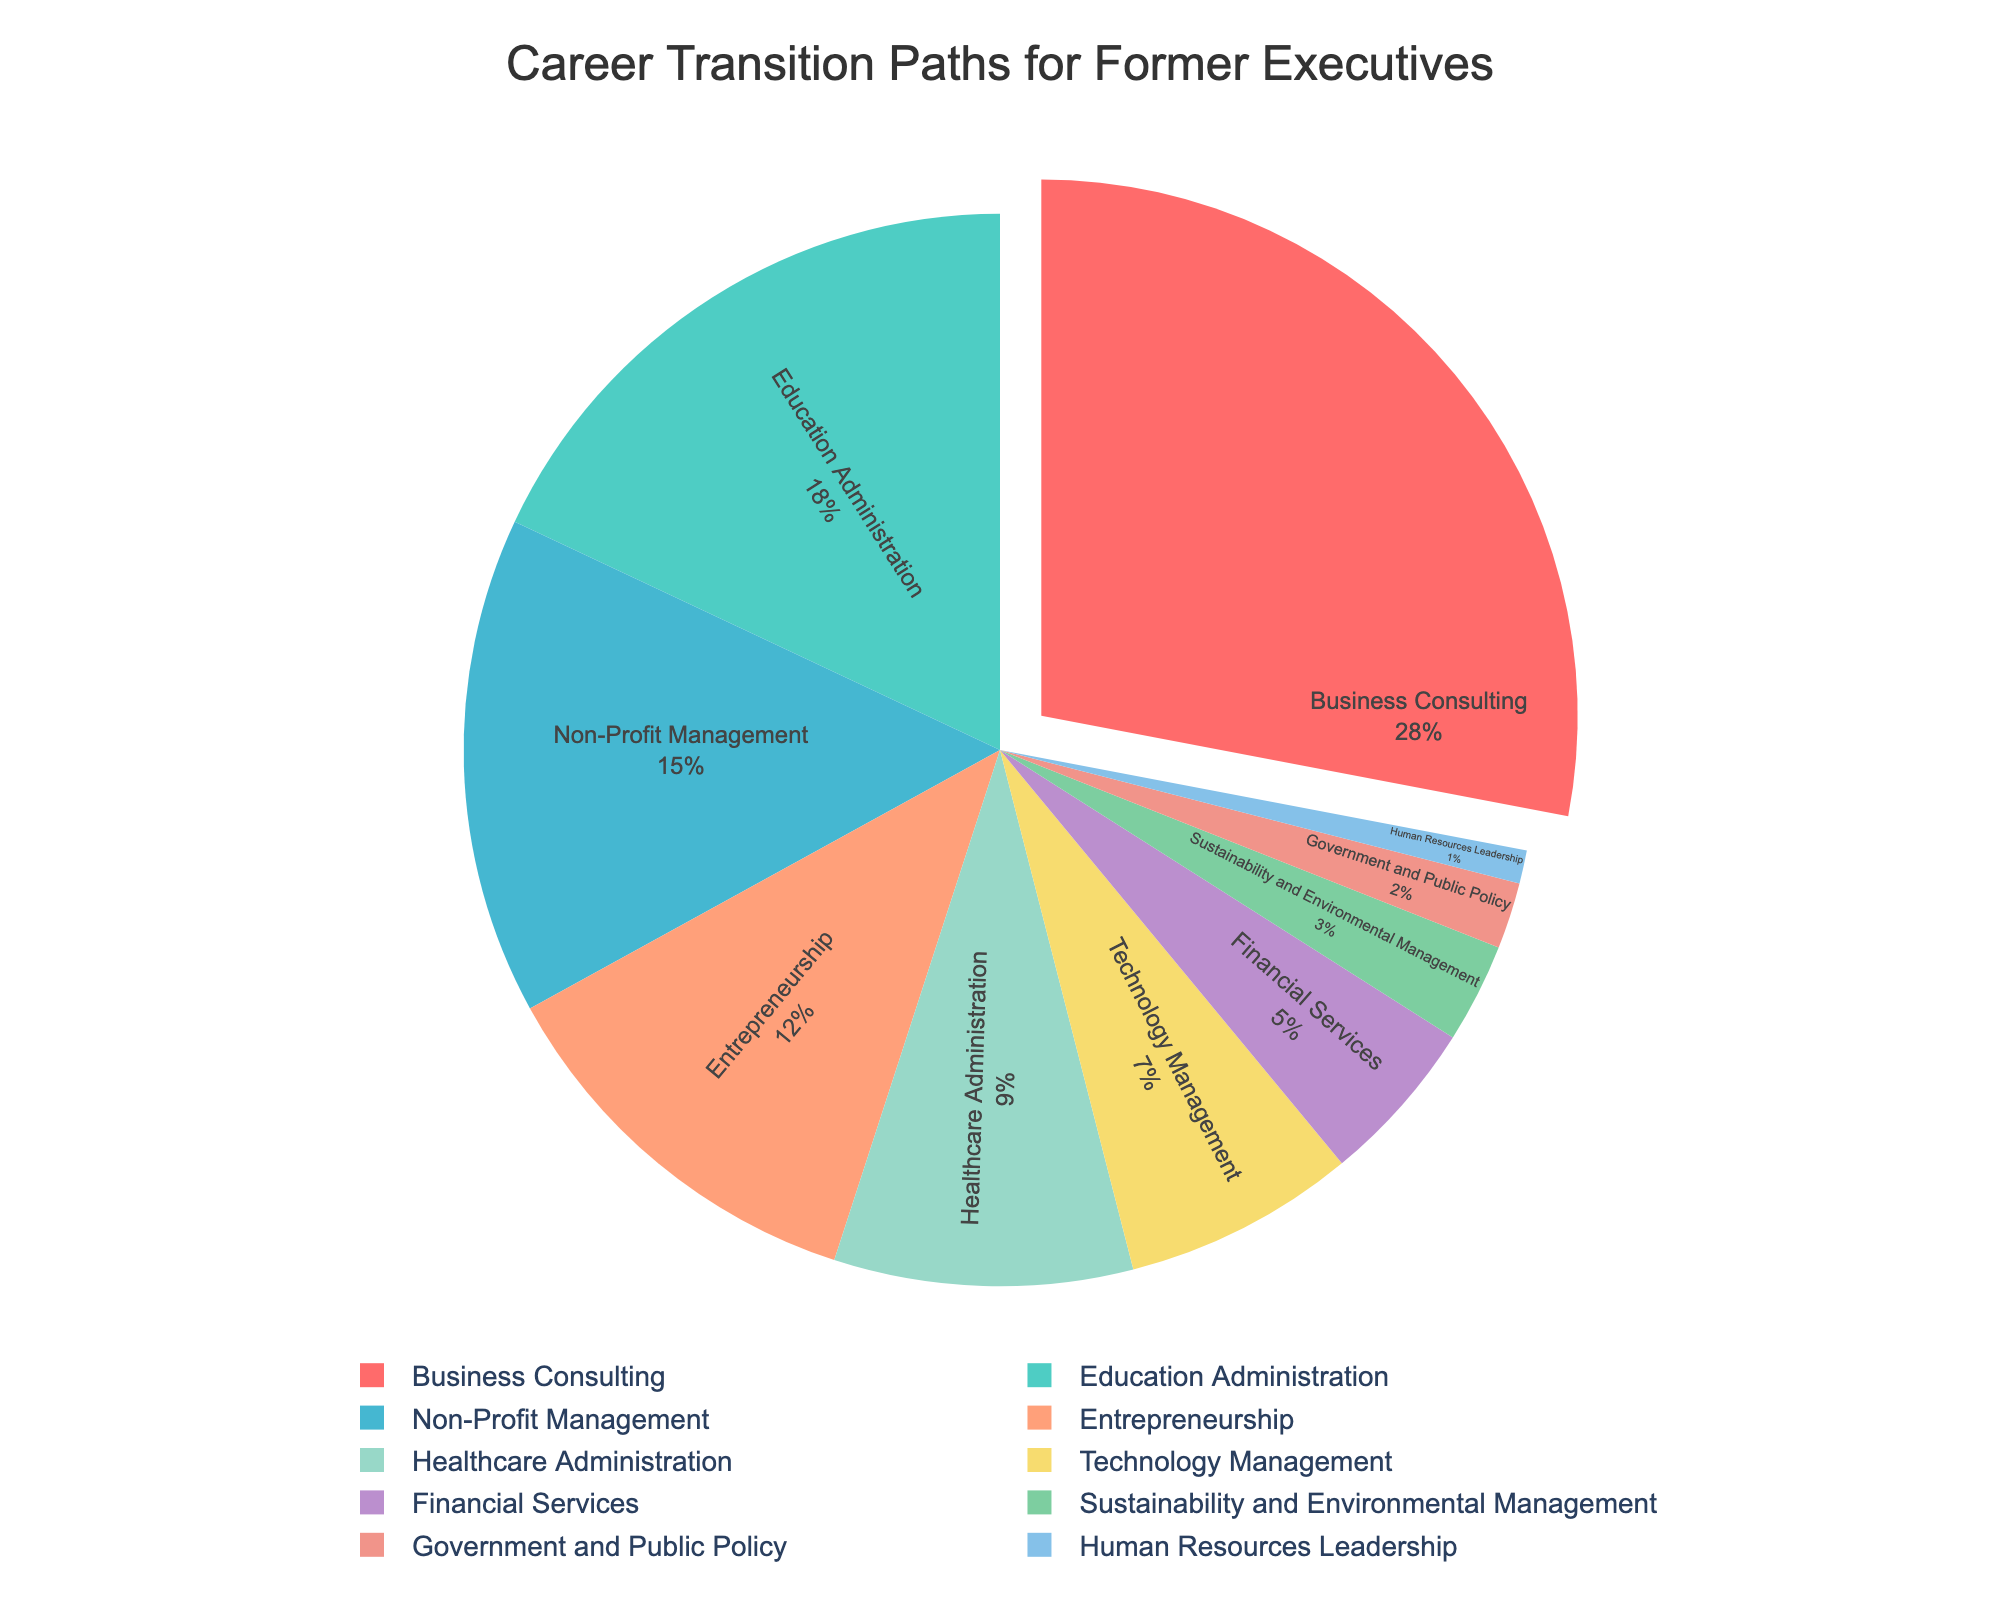Which career field has the largest percentage of former executives? Look at the pie chart for the field with the largest slice. The largest slice is labeled "Business Consulting".
Answer: Business Consulting What is the total percentage of former executives entering Technology Management and Financial Services? Sum the percentages of Technology Management (7%) and Financial Services (5%): 7 + 5 = 12.
Answer: 12% Is the percentage of former executives entering Education Administration greater than that of those entering Non-Profit Management? Compare the slices labeled "Education Administration" (18%) and "Non-Profit Management" (15%). 18 is greater than 15.
Answer: Yes Which fields have a smaller percentage than Healthcare Administration? Identify the slices with a percentage lower than Healthcare Administration (9%): Technology Management (7%), Financial Services (5%), Sustainability and Environmental Management (3%), Government and Public Policy (2%), and Human Resources Leadership (1%).
Answer: Technology Management, Financial Services, Sustainability and Environmental Management, Government and Public Policy, Human Resources Leadership What is the combined percentage of former executives transitioning into Entrepreneurship, Sustainability and Environmental Management, and Government and Public Policy? Sum the percentages: Entrepreneurship (12%), Sustainability and Environmental Management (3%), and Government and Public Policy (2%): 12 + 3 + 2 = 17.
Answer: 17% Which color represents Business Consulting on the pie chart? Identify the color of the largest slice, which is labeled "Business Consulting". The color is red.
Answer: Red By how many percentage points does the Business Consulting field exceed the Entrepreneurship field? Subtract the percentage of Entrepreneurship (12%) from Business Consulting (28%): 28 - 12 = 16.
Answer: 16 percentage points List the fields with the top three percentages of former executives. Identify the slices with the top three percentages: Business Consulting (28%), Education Administration (18%), and Non-Profit Management (15%).
Answer: Business Consulting, Education Administration, Non-Profit Management What is the percentage difference between Non-Profit Management and Healthcare Administration? Subtract the percentage of Healthcare Administration (9%) from Non-Profit Management (15%): 15 - 9 = 6.
Answer: 6% Which fields have a share of less than 5%? Identify the slices with a percentage less than 5%: Government and Public Policy (2%) and Human Resources Leadership (1%).
Answer: Government and Public Policy, Human Resources Leadership 